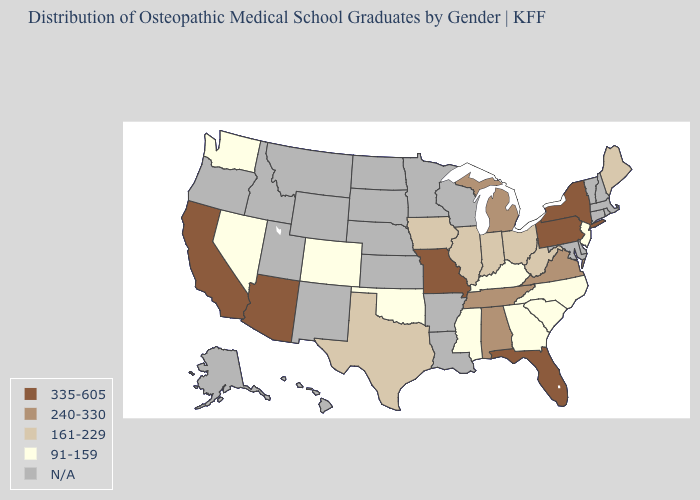What is the lowest value in states that border Arkansas?
Short answer required. 91-159. Name the states that have a value in the range 91-159?
Concise answer only. Colorado, Georgia, Kentucky, Mississippi, Nevada, New Jersey, North Carolina, Oklahoma, South Carolina, Washington. What is the value of Georgia?
Concise answer only. 91-159. What is the value of Iowa?
Concise answer only. 161-229. What is the highest value in the South ?
Be succinct. 335-605. What is the highest value in the USA?
Keep it brief. 335-605. Among the states that border Nebraska , which have the highest value?
Be succinct. Missouri. What is the value of Montana?
Give a very brief answer. N/A. What is the value of New Hampshire?
Write a very short answer. N/A. Does Maine have the highest value in the Northeast?
Short answer required. No. What is the highest value in the USA?
Quick response, please. 335-605. What is the lowest value in the Northeast?
Write a very short answer. 91-159. 